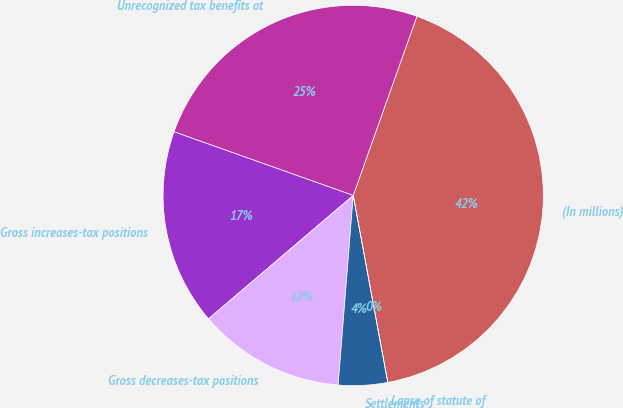Convert chart to OTSL. <chart><loc_0><loc_0><loc_500><loc_500><pie_chart><fcel>(In millions)<fcel>Unrecognized tax benefits at<fcel>Gross increases-tax positions<fcel>Gross decreases-tax positions<fcel>Settlements<fcel>Lapse of statute of<nl><fcel>41.66%<fcel>25.0%<fcel>16.67%<fcel>12.5%<fcel>4.17%<fcel>0.0%<nl></chart> 